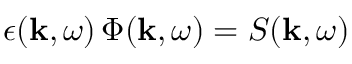<formula> <loc_0><loc_0><loc_500><loc_500>\epsilon ( k , \omega ) \, \Phi ( k , \omega ) = S ( k , \omega )</formula> 